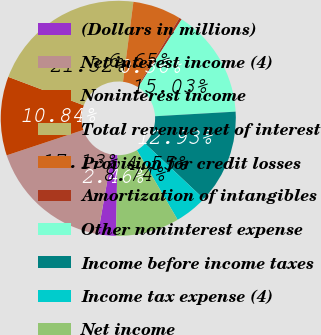Convert chart. <chart><loc_0><loc_0><loc_500><loc_500><pie_chart><fcel>(Dollars in millions)<fcel>Net interest income (4)<fcel>Noninterest income<fcel>Total revenue net of interest<fcel>Provision for credit losses<fcel>Amortization of intangibles<fcel>Other noninterest expense<fcel>Income before income taxes<fcel>Income tax expense (4)<fcel>Net income<nl><fcel>2.46%<fcel>17.13%<fcel>10.84%<fcel>21.32%<fcel>6.65%<fcel>0.36%<fcel>15.03%<fcel>12.93%<fcel>4.55%<fcel>8.74%<nl></chart> 